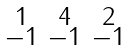Convert formula to latex. <formula><loc_0><loc_0><loc_500><loc_500>\begin{smallmatrix} 1 & 4 & 2 \\ - 1 & - 1 & - 1 \end{smallmatrix}</formula> 